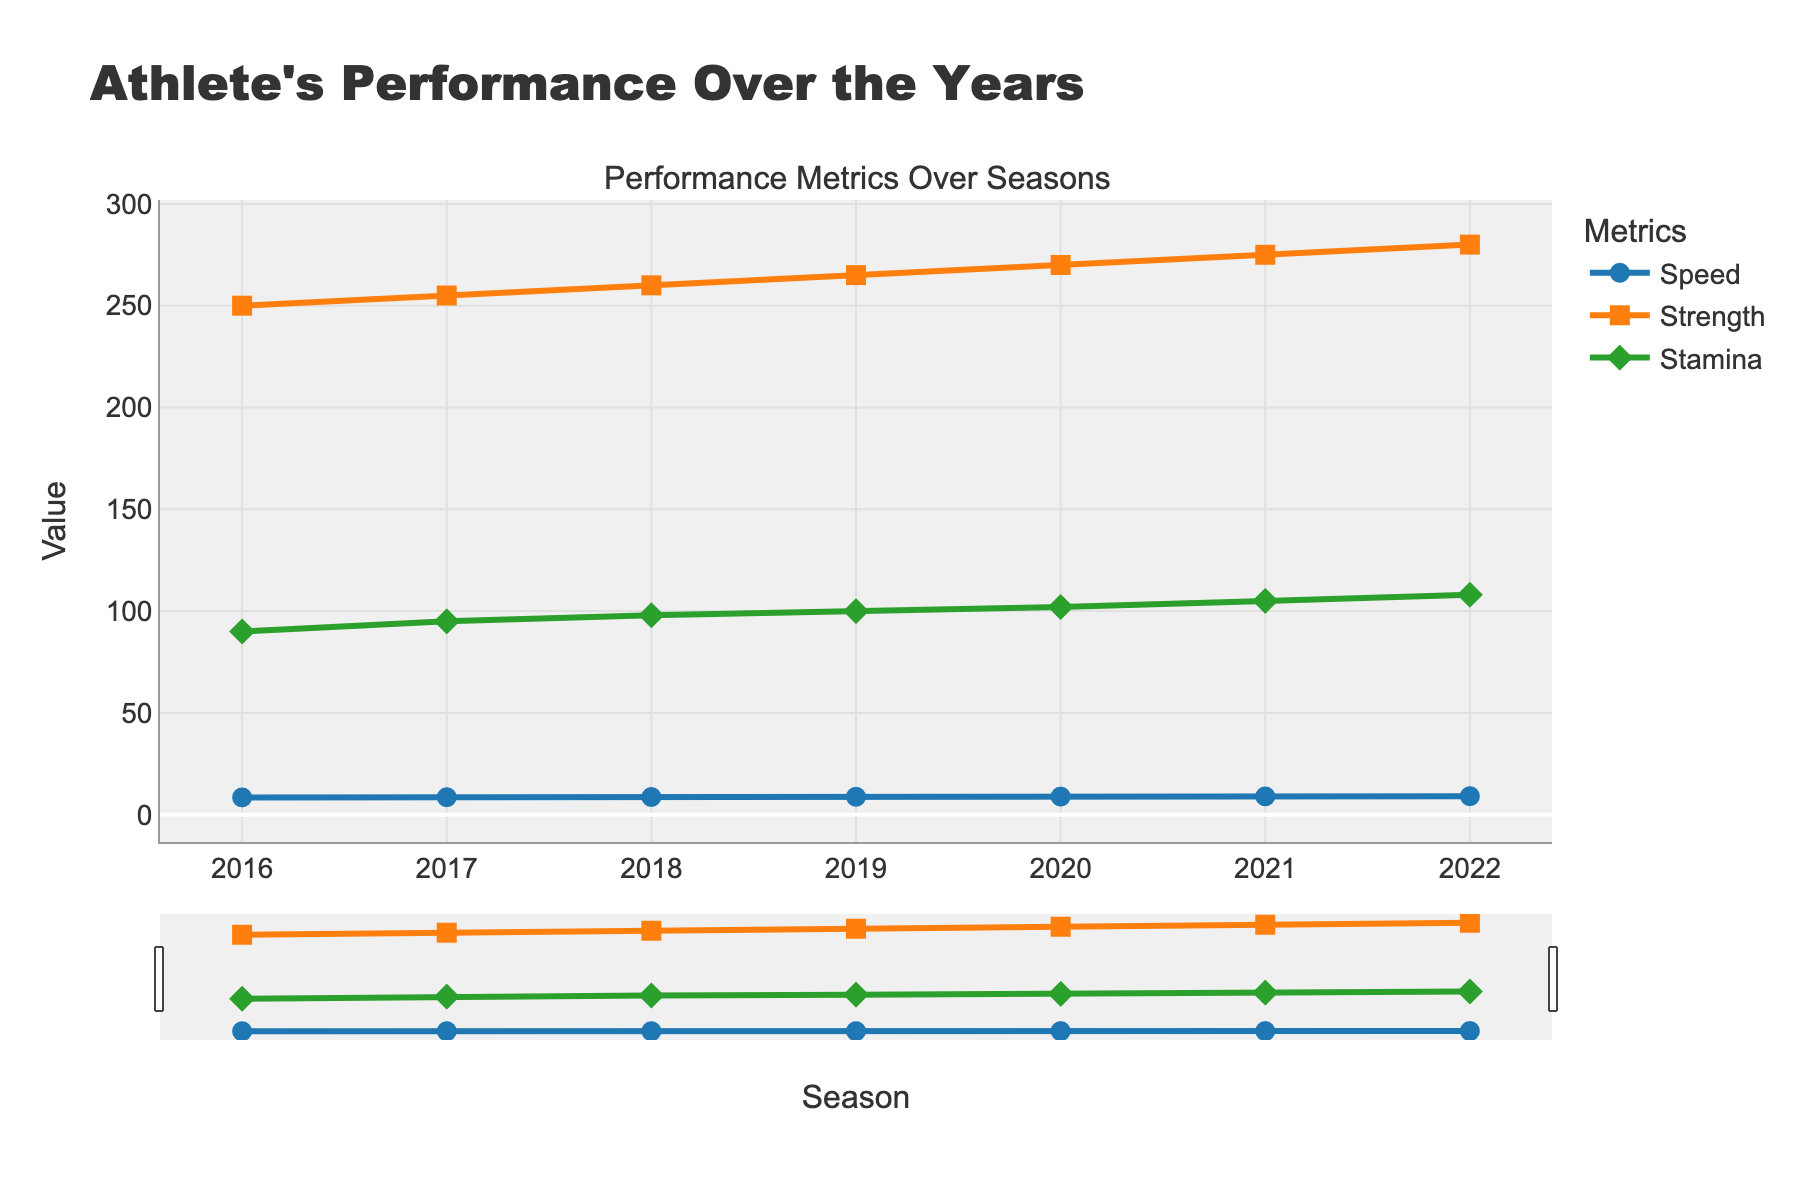How many different seasons are included in the plot? Count the number of unique x-axis labels. There are 7 seasons from 2016 to 2022.
Answer: 7 What is the trend of the Speed metric over the seasons? Observe the position of the 'Speed' line on the y-axis across the seasons. Speed increases gradually from 8.5 m/s in 2016 to 9.1 m/s in 2022.
Answer: Increasing Which metric has the highest final value in 2022? Compare the y-axis values of Speed, Strength, and Stamina for the year 2022. Stamina has the highest final value of 108 minutes.
Answer: Stamina What is the difference in Strength between 2016 and 2020? Subtract the Strength value in 2016 (250 kg) from the Strength value in 2020 (270 kg). 270 - 250 = 20 kg
Answer: 20 kg How does the increase in Stamina compare to the increase in Speed from 2016 to 2022? Calculate the difference in Stamina (108 - 90 = 18 minutes) and Speed (9.1 - 8.5 = 0.6 m/s) over the same period. The increase in Stamina (18 minutes) is larger compared to the increase in Speed (0.6 m/s).
Answer: Stamina increase is larger What is the average Speed over the seasons? Sum all the Speed values (8.5 + 8.6 + 8.7 + 8.8 + 8.9 + 9.0 + 9.1 = 61.6) and divide by the number of seasons (7). 61.6 / 7 = 8.8 m/s
Answer: 8.8 m/s During which season did the largest single-year increase in Strength occur? Check the Strength increments between consecutive years and identify the largest. The largest increase is from 2020 to 2021 (275 kg - 270 kg = 5 kg).
Answer: 2020 to 2021 Is there any season where all three metrics show a significant increase compared to the previous season? Compare the values of Speed, Strength, and Stamina between consecutive seasons to identify any point where all metrics show a notable increase. Between 2021 and 2022, all metrics show an increase: Speed (9.0 to 9.1), Strength (275 to 280), Stamina (105 to 108).
Answer: 2021 to 2022 